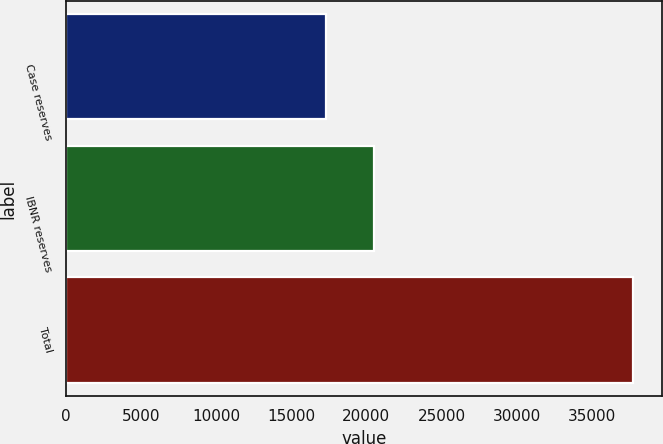<chart> <loc_0><loc_0><loc_500><loc_500><bar_chart><fcel>Case reserves<fcel>IBNR reserves<fcel>Total<nl><fcel>17307<fcel>20476<fcel>37783<nl></chart> 